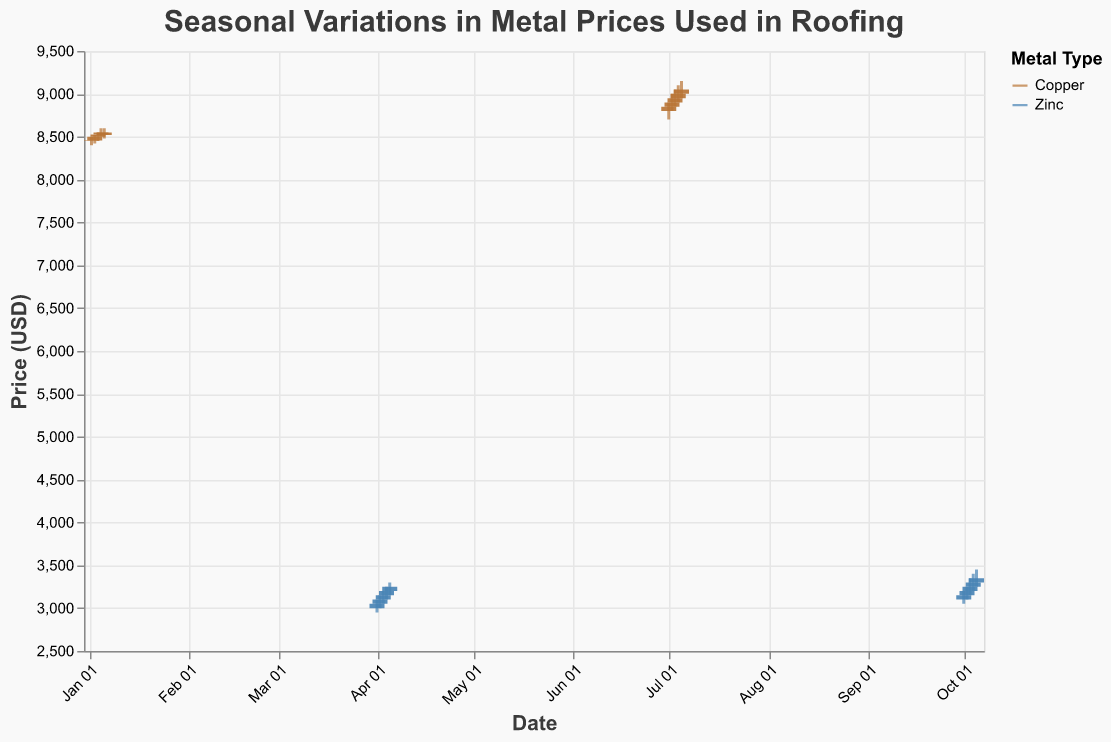What is the title of the chart? The title of the chart is located at the top and is prominently displayed. This information is directly visible in the chart.
Answer: Seasonal Variations in Metal Prices Used in Roofing How many different metals are shown in the chart? There are color-coded sections in the chart legend which list the two metals used in the data. The legend helps identify the distinct metal types presented.
Answer: Two (Copper and Zinc) Which metal shows a higher price range overall in any season? By comparing the vertical extent of the price bars (candlesticks) for each metal, it is evident which metal has higher values. The copper prices range around 8450-9050, whereas zinc is around 3000-3450.
Answer: Copper What is the closing price of Copper on July 2, 2023? Locate the date "July 2, 2023" on the x-axis and identify the corresponding candlestick bar for Copper. The closing price is marked by the top segment of the thicker part of the bar if it is green.
Answer: 8900 How does the volume of Copper trading compare between January and July? The volume of trading is represented by the size of the bars or circles, which indicates the relative amounts. By comparing these visual indicators for January and July, one can see if they are larger or smaller.
Answer: Higher in July What is the range between the highest and lowest price for Zinc on October 4, 2023? For the date "October 4, 2023", locate the corresponding candlestick for Zinc. The highest price (topmost point) minus the lowest price (bottommost point) gives the range.
Answer: 200 (3400 - 3200) How much did Copper's closing price increase from January to July? Compare the closing price of Copper on January 6, 2023, to the closing price on July 5, 2023, by locating these dates and identifying the closing segments of the respective bars. Then, subtract January's closing price from July's closing price.
Answer: 530 (9050 - 8520) Which metal had a more significant price rise within a month, any month in the dataset? By examining each metal’s candlesticks over their respective months, determine the difference in closing prices from the start to the end of that month. The metal with the larger overall increase is the one with the more significant rise.
Answer: Zinc in October (3350 - 3150 = 200) What was the highest trading volume for Zinc in April? For each date in April, check the values listed in the volume data for Zinc and identify the highest number present for any of those days.
Answer: 44000 Which metal showed a more stable price in October, considering daily fluctuations? Observe the vertical range (distance from the lowest to the highest point) of the candlestick bars for each day in October for both metals. The metal with less fluctuation in its daily bars shows more stable prices.
Answer: Zinc 